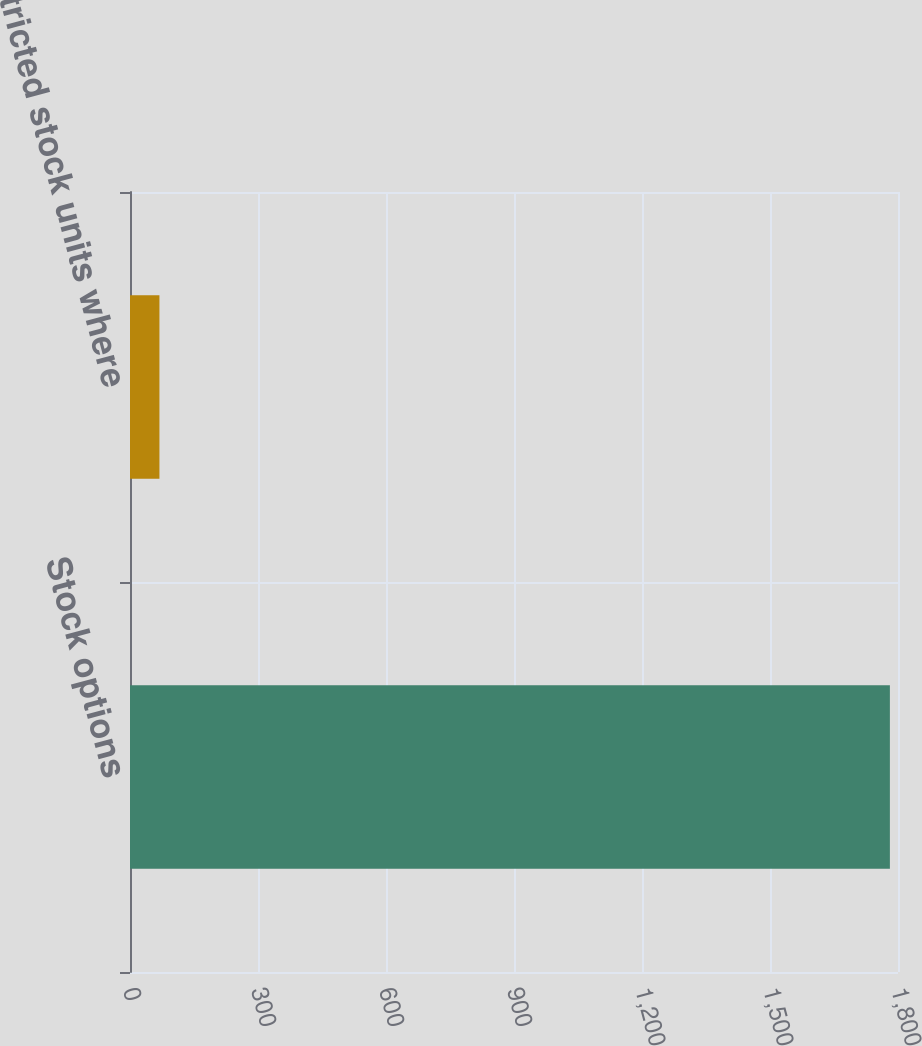<chart> <loc_0><loc_0><loc_500><loc_500><bar_chart><fcel>Stock options<fcel>Restricted stock units where<nl><fcel>1781<fcel>69<nl></chart> 